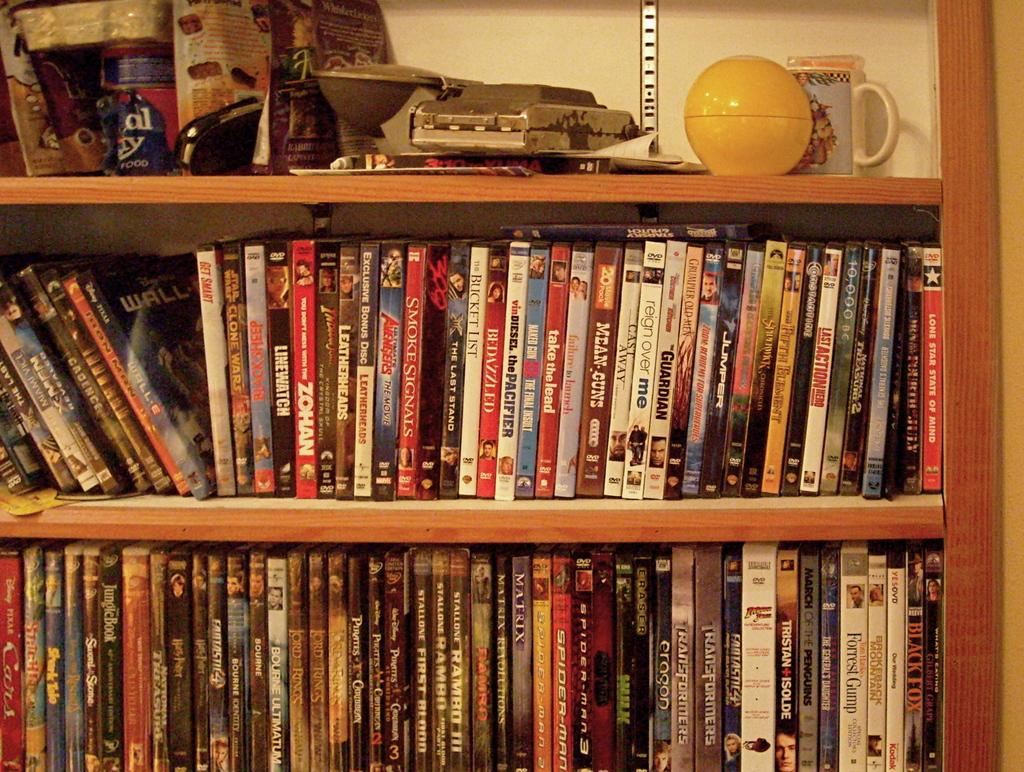Provide a one-sentence caption for the provided image. Bedazzled bunched in with other books on a shelf. 